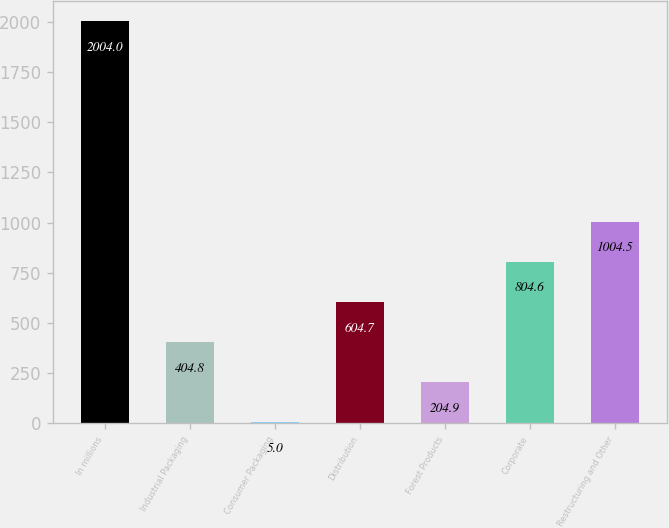<chart> <loc_0><loc_0><loc_500><loc_500><bar_chart><fcel>In millions<fcel>Industrial Packaging<fcel>Consumer Packaging<fcel>Distribution<fcel>Forest Products<fcel>Corporate<fcel>Restructuring and Other<nl><fcel>2004<fcel>404.8<fcel>5<fcel>604.7<fcel>204.9<fcel>804.6<fcel>1004.5<nl></chart> 